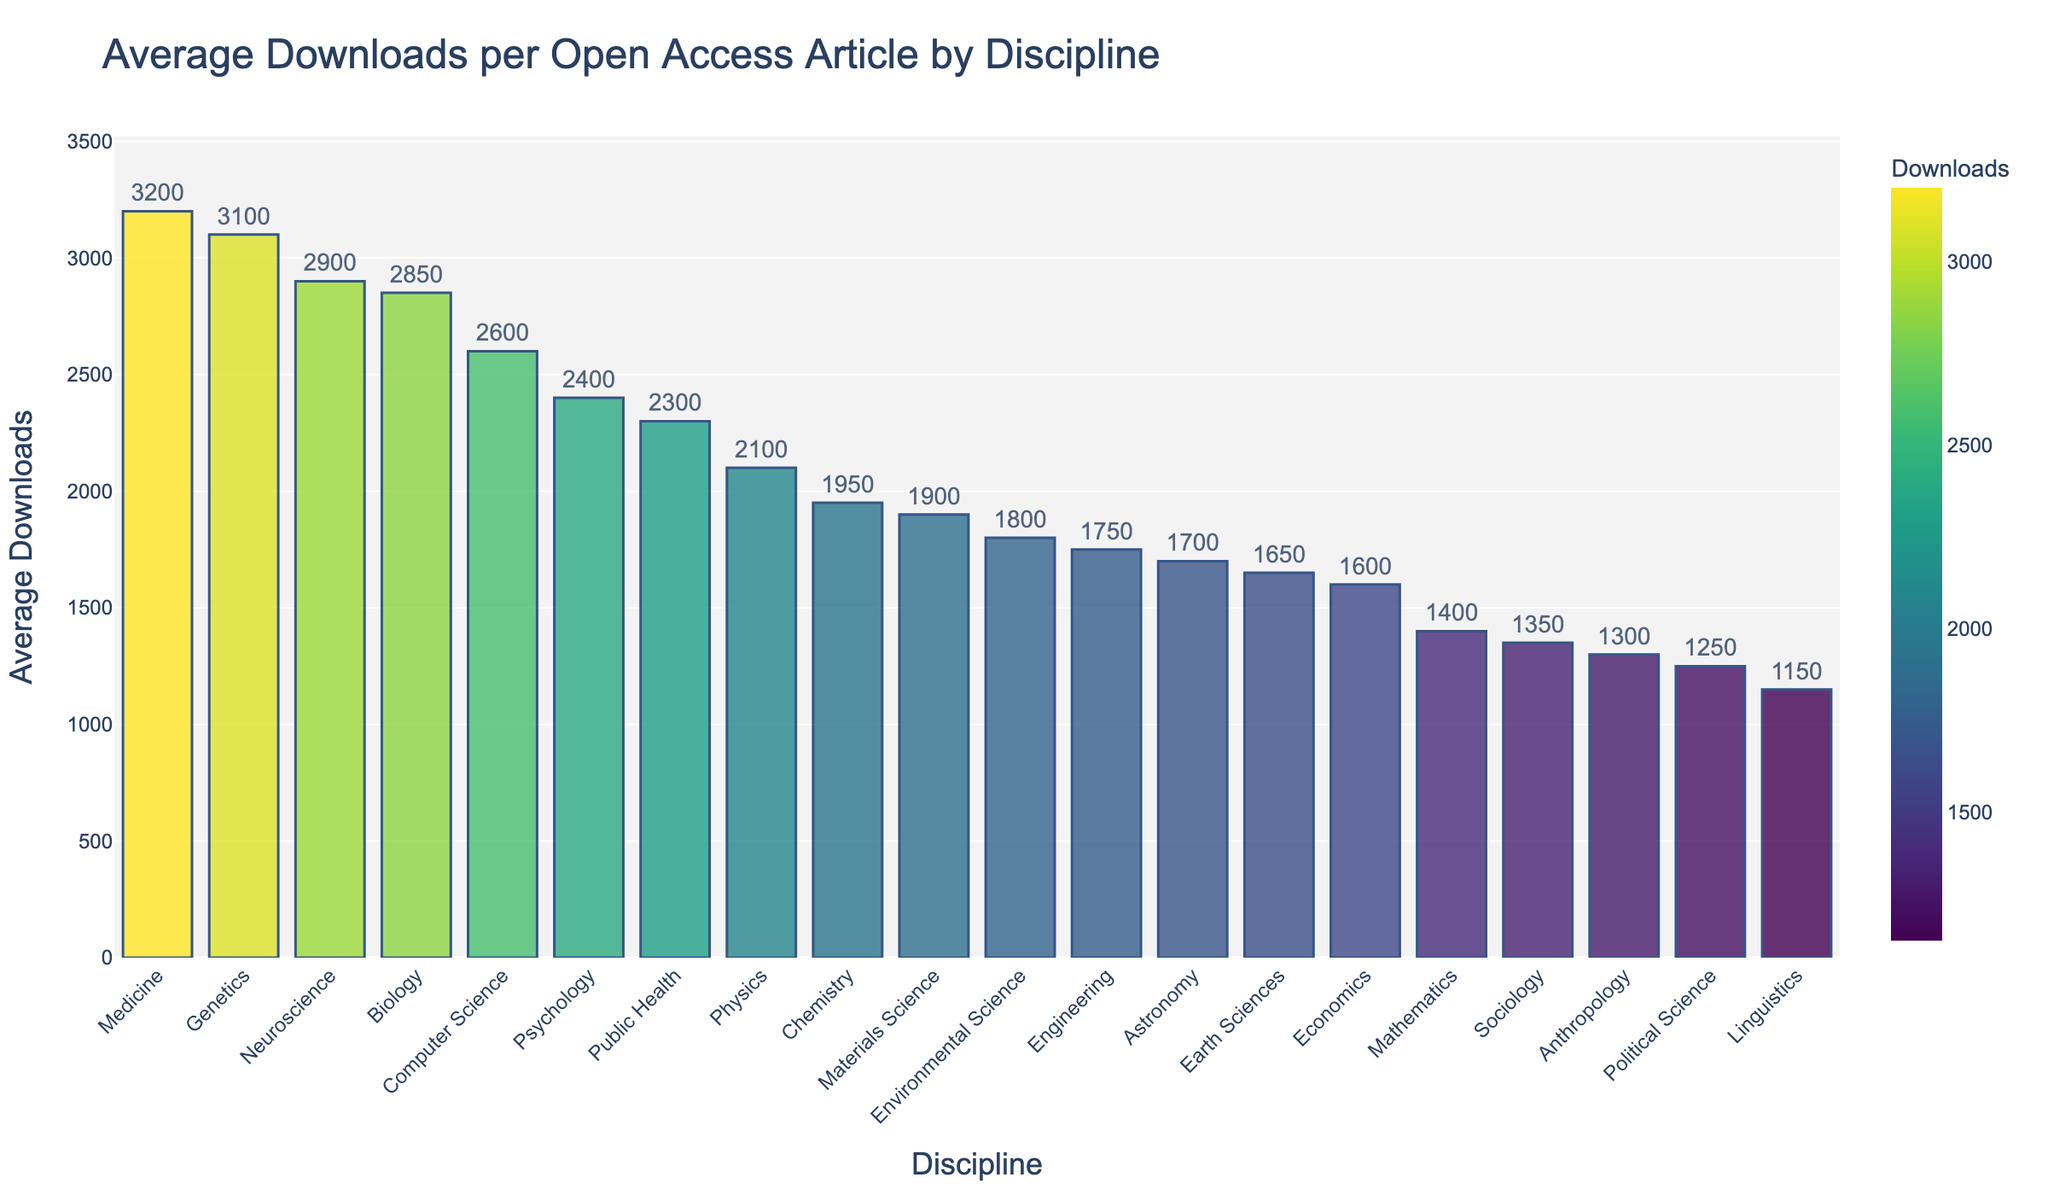Which discipline has the highest average downloads per article? Identify the discipline with the tallest bar in the figure, which represents the highest downloads.
Answer: Medicine What's the greatest difference in average downloads between two disciplines? Find the two disciplines with the maximum difference in the height of their corresponding bars. Compare the highest and lowest values. The difference is 3200 (Medicine) - 1150 (Linguistics) = 2050.
Answer: 2050 Which disciplines have an average download above 3000 per article? Identify the bars that exceed the y-axis value of 3000.
Answer: Medicine, Genetics, Neuroscience Compare the average downloads for Computer Science and Economics. Which one is higher? Check the heights of the bars for Computer Science and Economics. Computer Science has a taller bar than Economics.
Answer: Computer Science What is the median value of average downloads per article across all disciplines? Arrange the average download values in ascending order and find the middle value. With an odd number of disciplines (19), the median is the value at the 10th position, which is given by Public Health.
Answer: 2300 What's the sum of average downloads for Biology and Medicine? Add the average downloads for Biology (2850) and Medicine (3200). The sum is 2850 + 3200 = 6050.
Answer: 6050 Which discipline has downloads closest to 2000 per article? Find the bar corresponding to the average download value nearest to 2000. The closest is Chemistry at 1950.
Answer: Chemistry By how much does the average downloads for Sociology differ from Anthropology? Find the difference between the values for Sociology (1350) and Anthropology (1300). The difference is 1350 - 1300 = 50.
Answer: 50 How many disciplines have an average download value below 2000 per article? Count the bars with values less than 2000 on the y-axis. There are nine such disciplines: Chemistry, Environmental Science, Engineering, Economics, Mathematics, Sociology, Astronomy, Political Science, Linguistics, Anthropology, Earth Sciences.
Answer: 10 